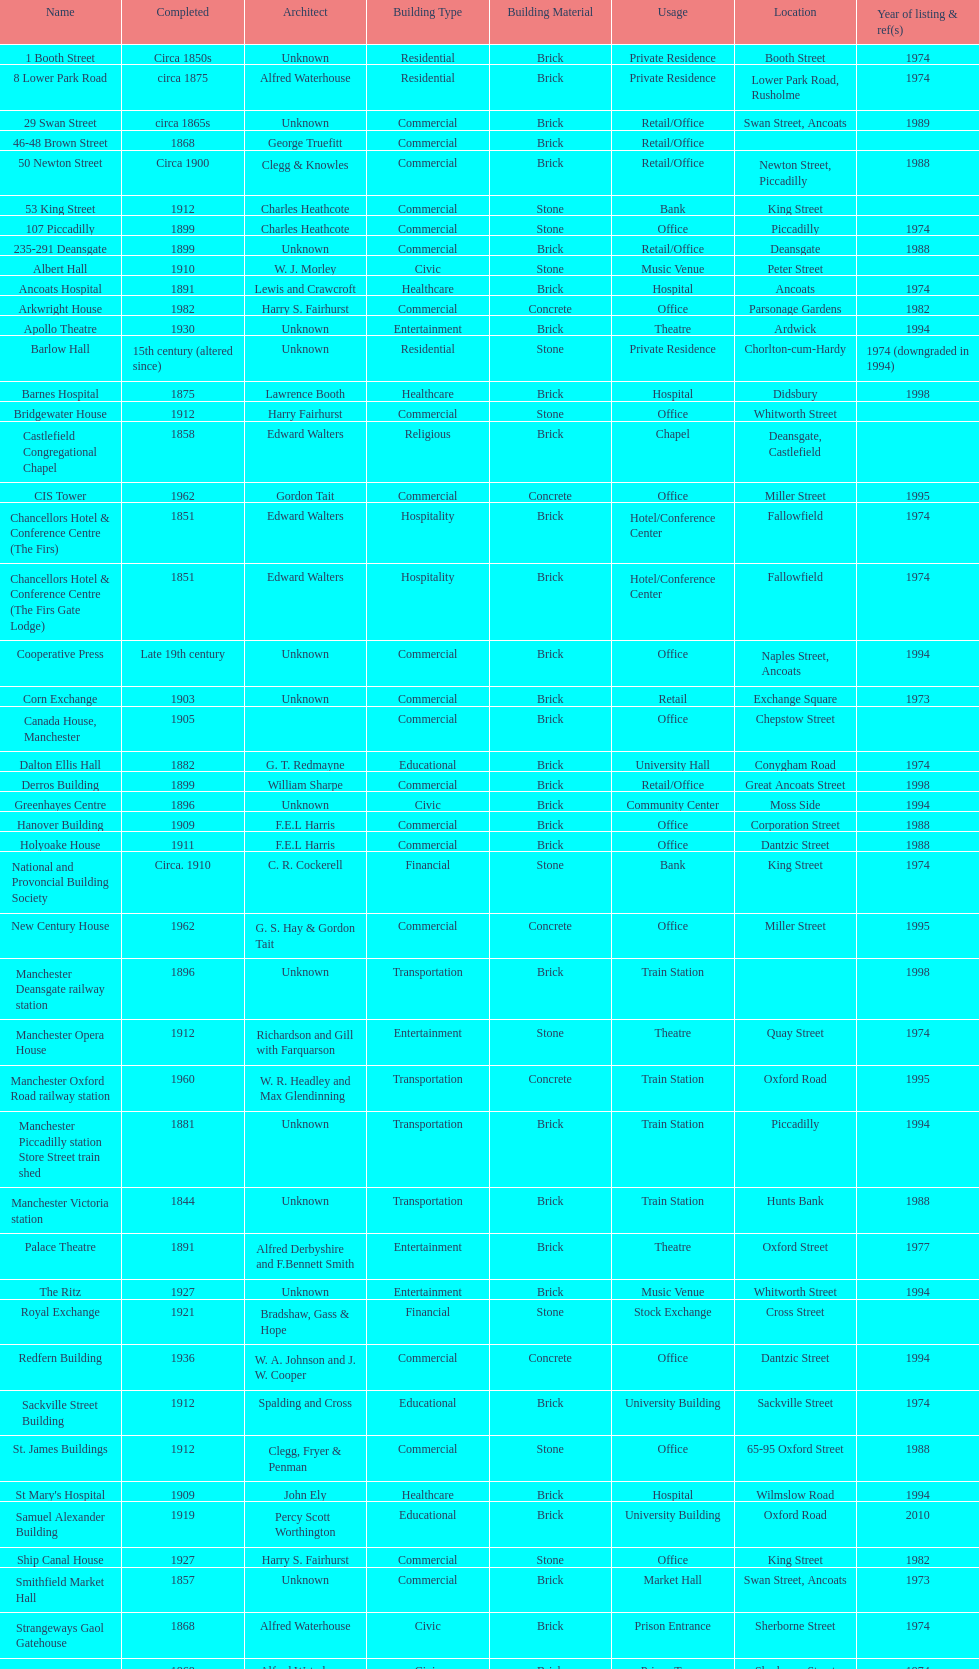Was charles heathcote the architect of ancoats hospital and apollo theatre? No. 